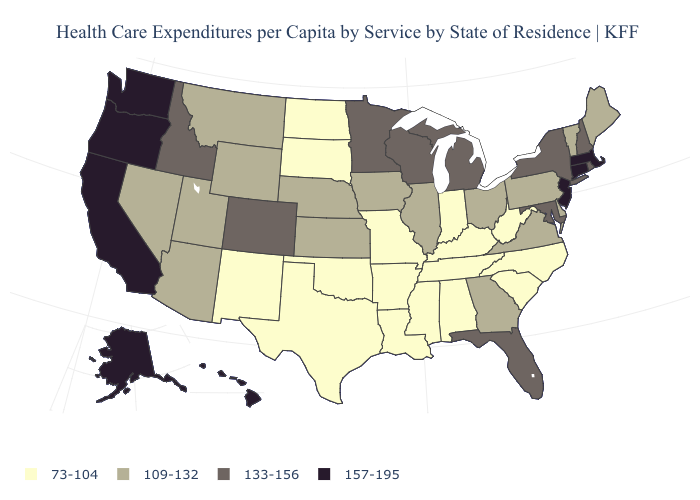Among the states that border North Dakota , does Minnesota have the lowest value?
Give a very brief answer. No. What is the value of Louisiana?
Short answer required. 73-104. Does Connecticut have the highest value in the USA?
Quick response, please. Yes. Name the states that have a value in the range 109-132?
Be succinct. Arizona, Delaware, Georgia, Illinois, Iowa, Kansas, Maine, Montana, Nebraska, Nevada, Ohio, Pennsylvania, Utah, Vermont, Virginia, Wyoming. Among the states that border Kentucky , which have the highest value?
Be succinct. Illinois, Ohio, Virginia. Does Alaska have the highest value in the USA?
Short answer required. Yes. Among the states that border Pennsylvania , which have the highest value?
Be succinct. New Jersey. What is the value of New Hampshire?
Quick response, please. 133-156. What is the lowest value in the USA?
Concise answer only. 73-104. Does California have the highest value in the USA?
Keep it brief. Yes. What is the highest value in the USA?
Write a very short answer. 157-195. Does the map have missing data?
Short answer required. No. What is the value of Nebraska?
Keep it brief. 109-132. What is the highest value in the South ?
Short answer required. 133-156. What is the value of Texas?
Answer briefly. 73-104. 